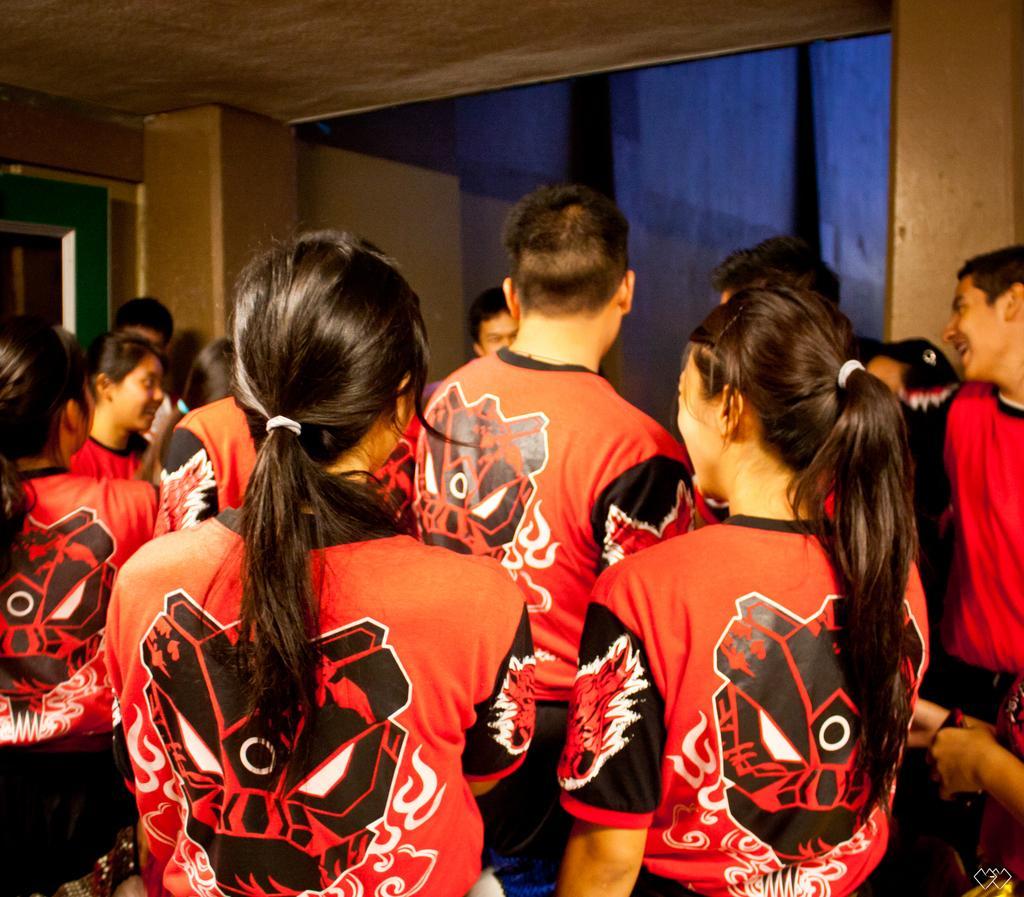Describe this image in one or two sentences. This is the picture of a room in which there are some people wearing same dress and to the side there is an other person in red top. 